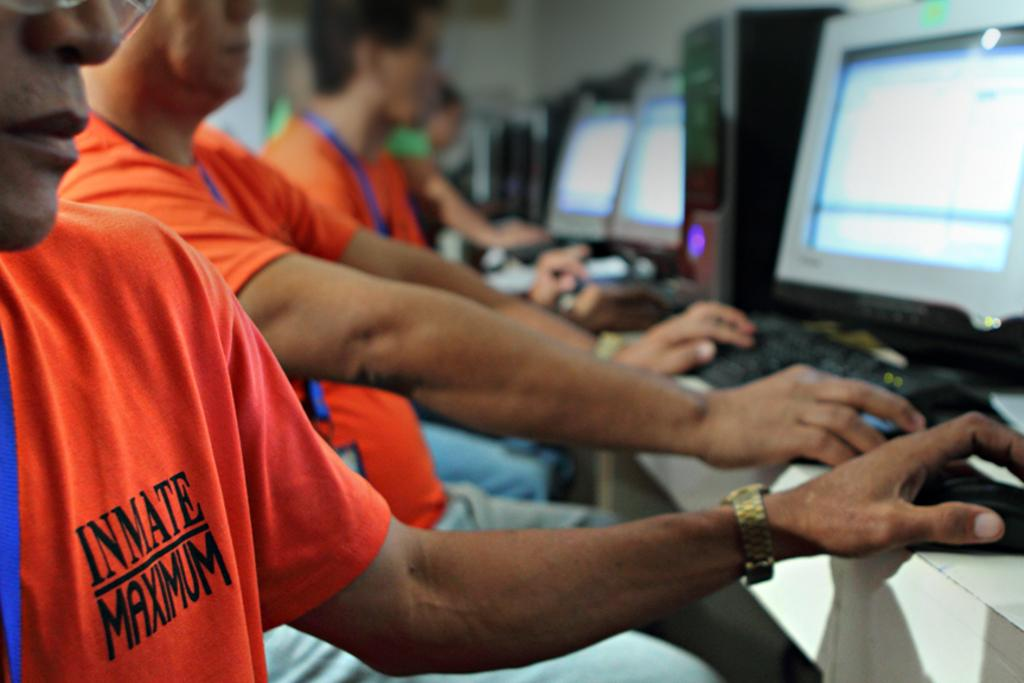<image>
Provide a brief description of the given image. Several people work at computer terminals wearing orange shirts that say Inmate Maximum. 